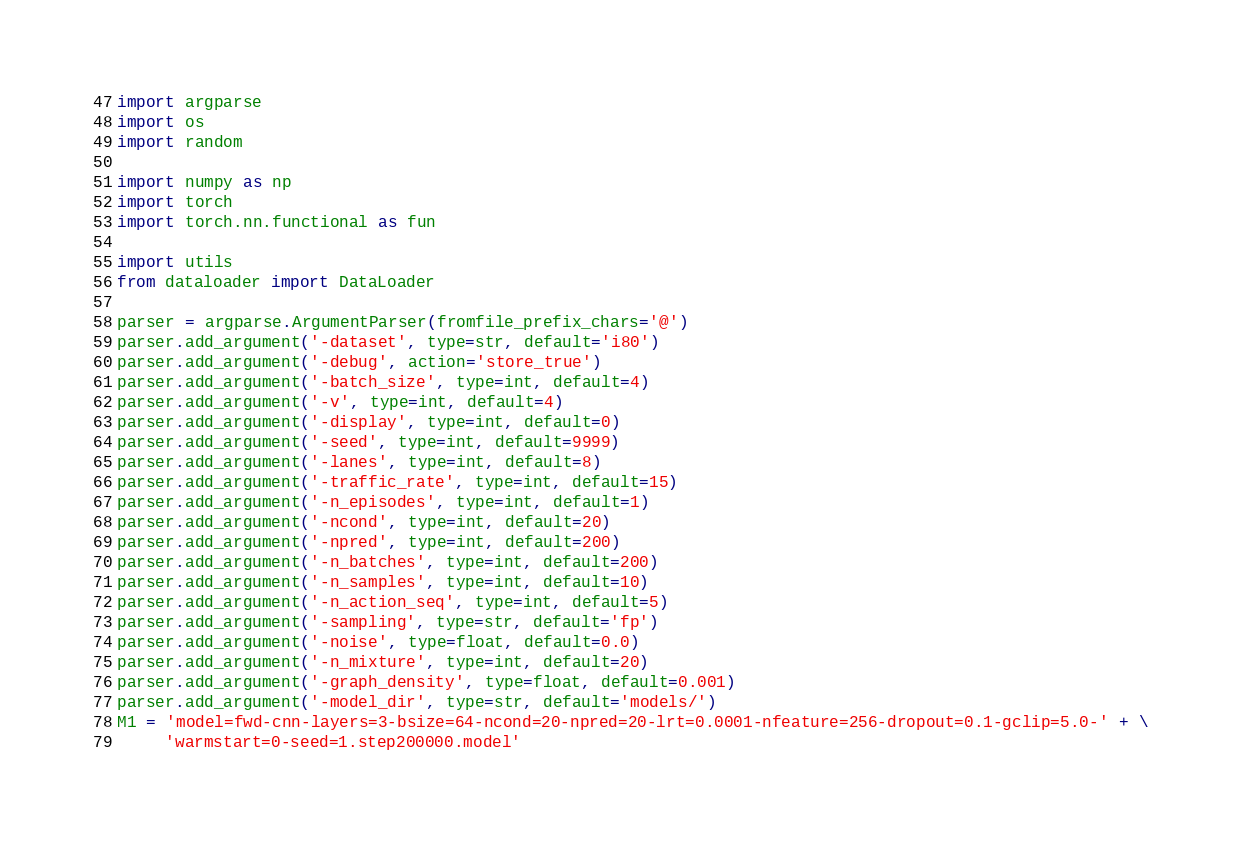Convert code to text. <code><loc_0><loc_0><loc_500><loc_500><_Python_>import argparse
import os
import random

import numpy as np
import torch
import torch.nn.functional as fun

import utils
from dataloader import DataLoader

parser = argparse.ArgumentParser(fromfile_prefix_chars='@')
parser.add_argument('-dataset', type=str, default='i80')
parser.add_argument('-debug', action='store_true')
parser.add_argument('-batch_size', type=int, default=4)
parser.add_argument('-v', type=int, default=4)
parser.add_argument('-display', type=int, default=0)
parser.add_argument('-seed', type=int, default=9999)
parser.add_argument('-lanes', type=int, default=8)
parser.add_argument('-traffic_rate', type=int, default=15)
parser.add_argument('-n_episodes', type=int, default=1)
parser.add_argument('-ncond', type=int, default=20)
parser.add_argument('-npred', type=int, default=200)
parser.add_argument('-n_batches', type=int, default=200)
parser.add_argument('-n_samples', type=int, default=10)
parser.add_argument('-n_action_seq', type=int, default=5)
parser.add_argument('-sampling', type=str, default='fp')
parser.add_argument('-noise', type=float, default=0.0)
parser.add_argument('-n_mixture', type=int, default=20)
parser.add_argument('-graph_density', type=float, default=0.001)
parser.add_argument('-model_dir', type=str, default='models/')
M1 = 'model=fwd-cnn-layers=3-bsize=64-ncond=20-npred=20-lrt=0.0001-nfeature=256-dropout=0.1-gclip=5.0-' + \
     'warmstart=0-seed=1.step200000.model'</code> 